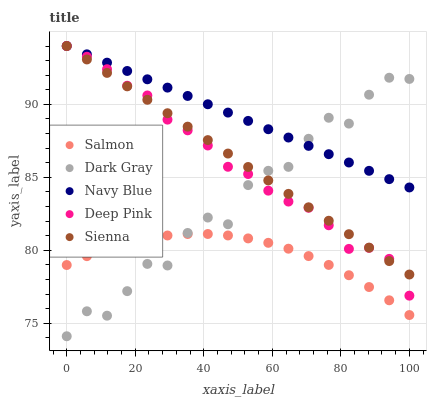Does Salmon have the minimum area under the curve?
Answer yes or no. Yes. Does Navy Blue have the maximum area under the curve?
Answer yes or no. Yes. Does Deep Pink have the minimum area under the curve?
Answer yes or no. No. Does Deep Pink have the maximum area under the curve?
Answer yes or no. No. Is Sienna the smoothest?
Answer yes or no. Yes. Is Dark Gray the roughest?
Answer yes or no. Yes. Is Navy Blue the smoothest?
Answer yes or no. No. Is Navy Blue the roughest?
Answer yes or no. No. Does Dark Gray have the lowest value?
Answer yes or no. Yes. Does Deep Pink have the lowest value?
Answer yes or no. No. Does Sienna have the highest value?
Answer yes or no. Yes. Does Salmon have the highest value?
Answer yes or no. No. Is Salmon less than Sienna?
Answer yes or no. Yes. Is Navy Blue greater than Salmon?
Answer yes or no. Yes. Does Sienna intersect Deep Pink?
Answer yes or no. Yes. Is Sienna less than Deep Pink?
Answer yes or no. No. Is Sienna greater than Deep Pink?
Answer yes or no. No. Does Salmon intersect Sienna?
Answer yes or no. No. 